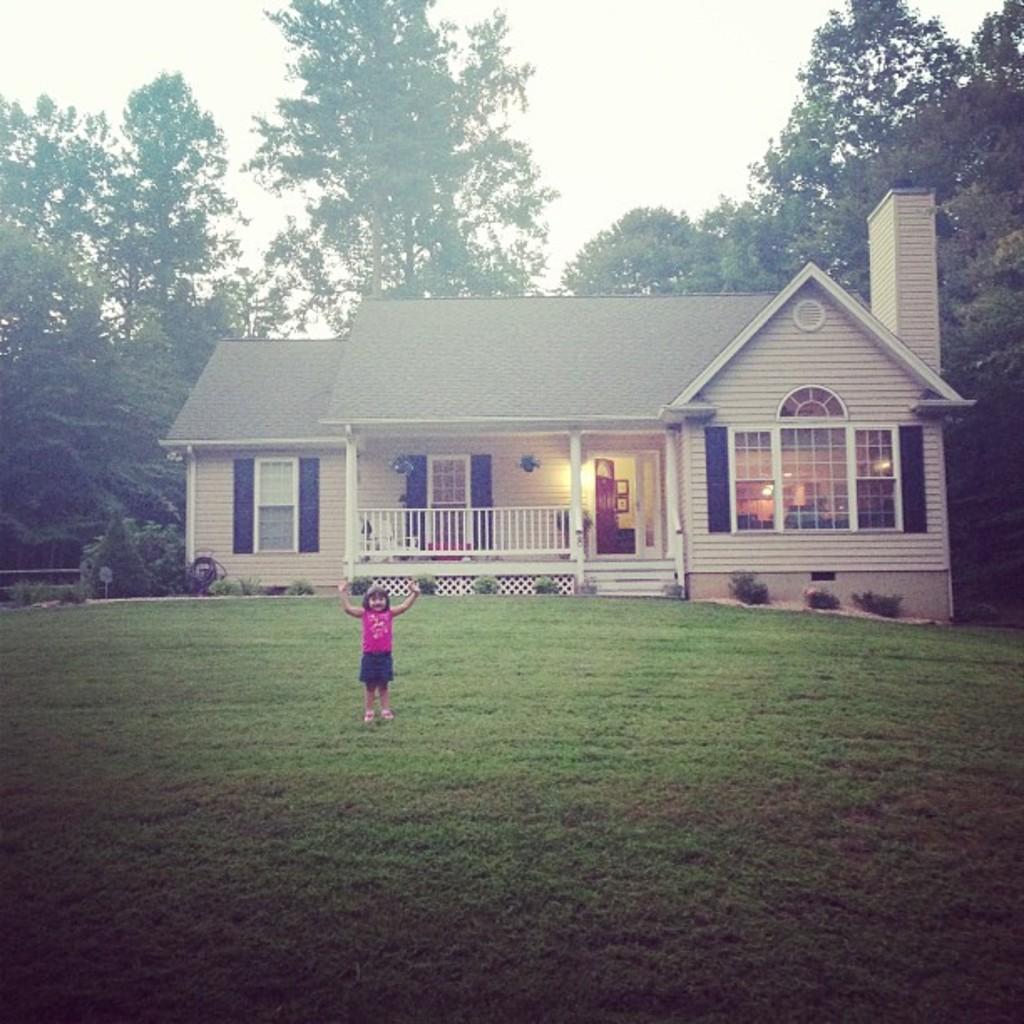In one or two sentences, can you explain what this image depicts? In this picture we can see a girl standing on the ground, house with windows, door, trees and in the background we can see the sky. 